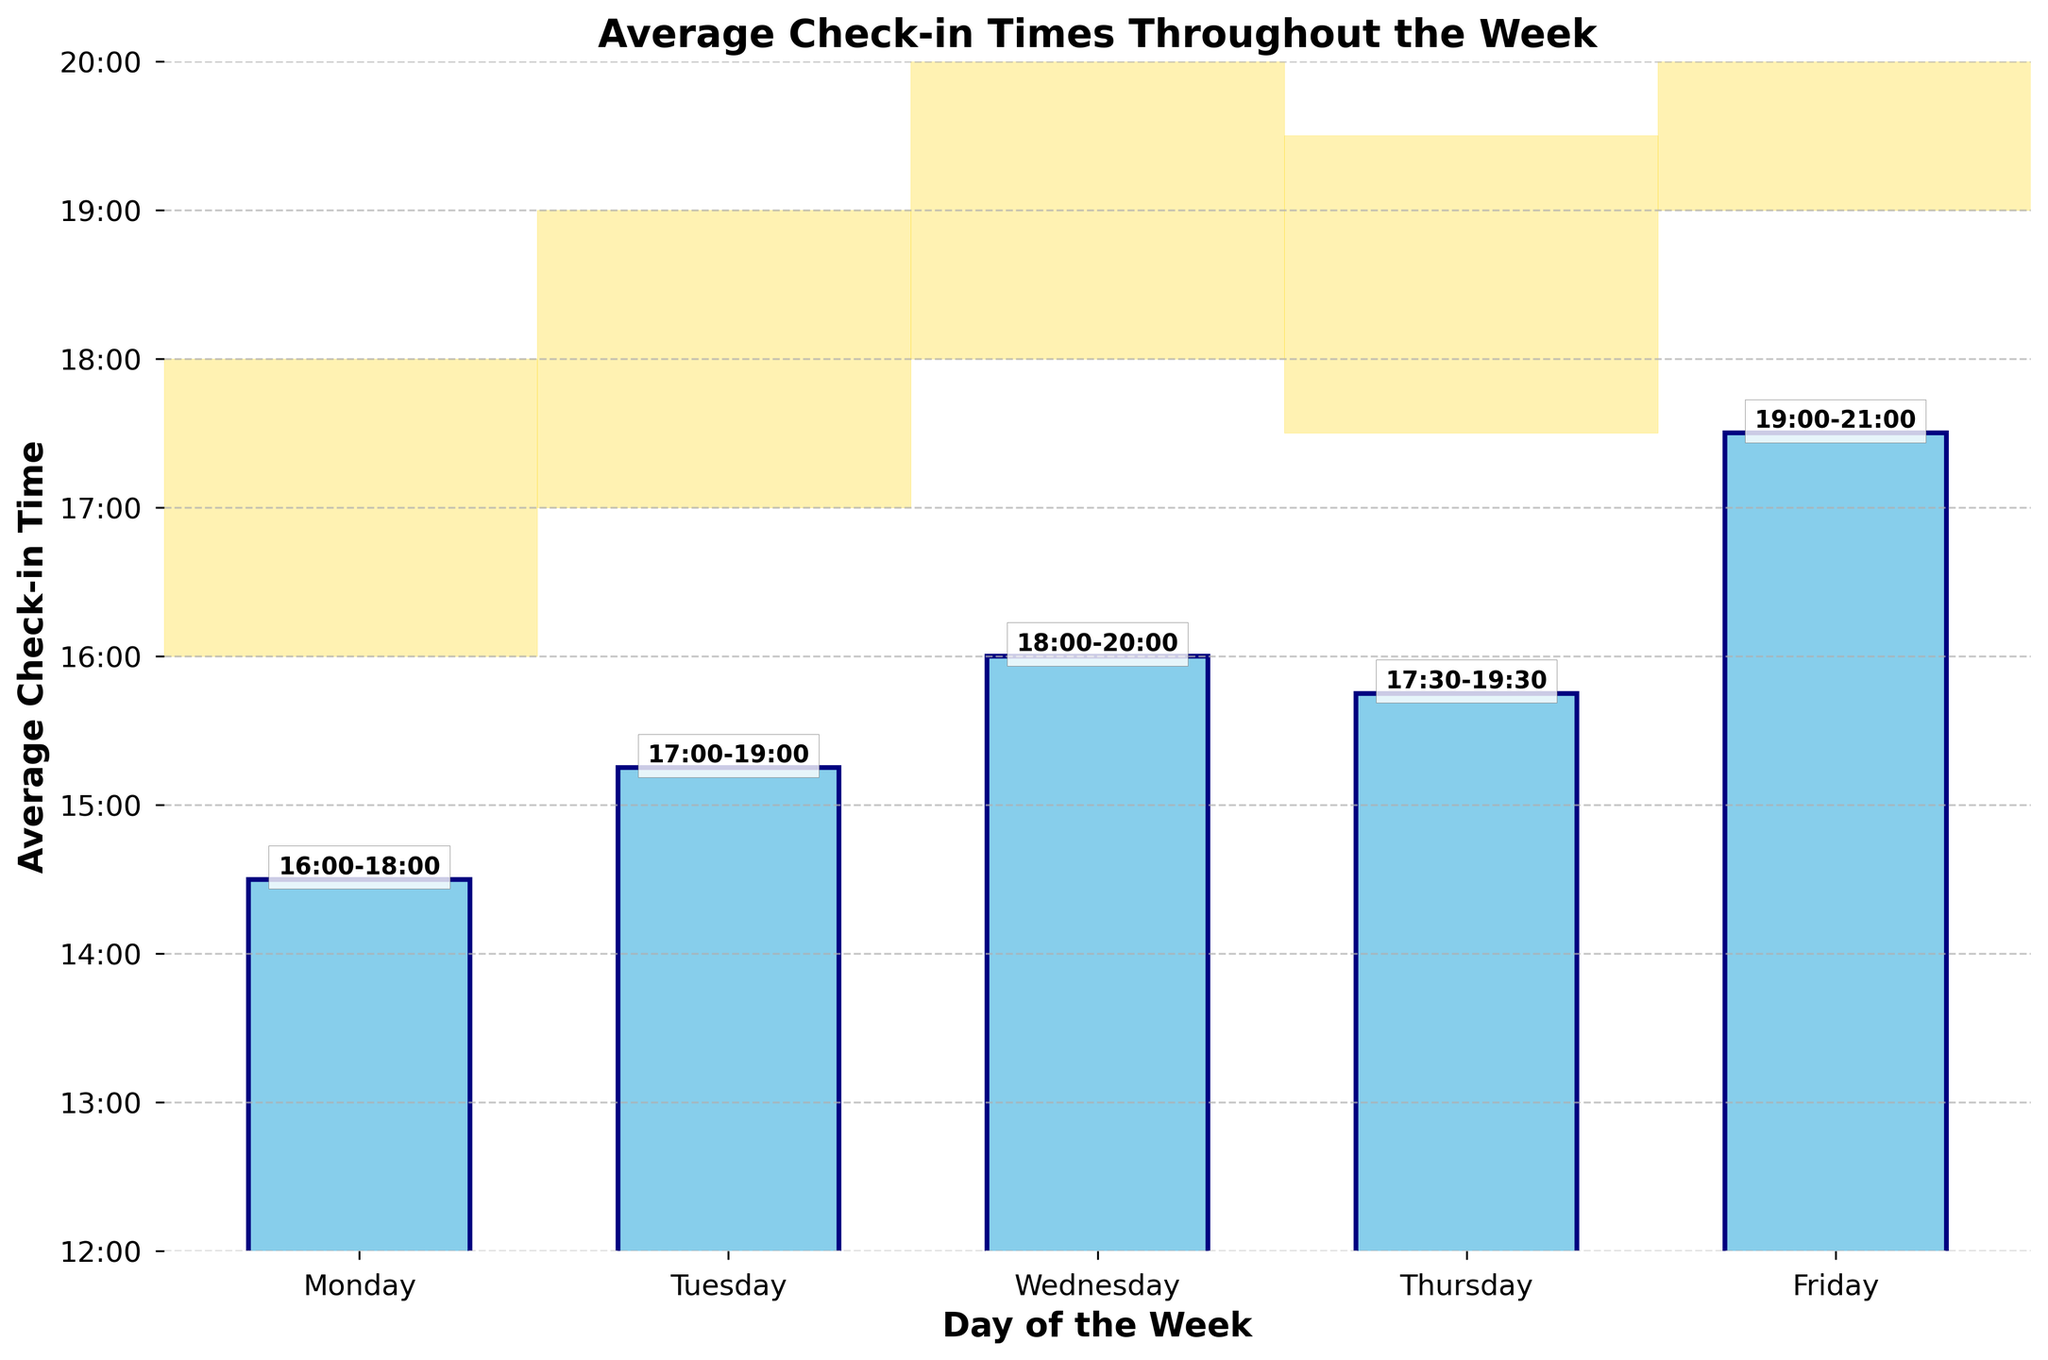What's the peak hour for check-ins on Friday? Look at the bar for Friday and note the highlighted peak hour text above the bar. It indicates peak hours from 19:00 to 21:00.
Answer: 19:00-21:00 What is the difference between the average check-in time on Monday and Friday? Convert the check-in times to hours: Monday is 14.5 hours (14:30) and Friday is 17.5 hours (17:30). Subtract Monday's time from Friday's time: 17.5 - 14.5 = 3 hours.
Answer: 3 hours Which day has the latest average check-in time? Compare the height of the bars on each day. The bar for Friday is the highest, indicating the latest average check-in time.
Answer: Friday By how much is the average check-in time on Wednesday later than on Tuesday? Convert the check-in times to hours: Tuesday is 15.25 hours (15:15) and Wednesday is 16 hours (16:00). Subtract Tuesday's time from Wednesday's time: 16 - 15.25 = 0.75 hours.
Answer: 0.75 hours On which day is the peak check-in time range the earliest? Compare the starting times of the peak hours for each day. Monday's peak hours start at 16:00, which is the earliest.
Answer: Monday How much earlier is the average check-in time on Monday compared to Thursday? Convert the check-in times to hours: Monday is 14.5 hours (14:30) and Thursday is 15.75 hours (15:45). Subtract Thursday's time from Monday's time: 15.75 - 14.5 = 1.25 hours.
Answer: 1.25 hours What is the total duration of the peak check-in hours on Wednesday? Check Wednesday's peak hour range: 18:00 to 20:00. Calculate the duration: 20 - 18 = 2 hours.
Answer: 2 hours How does the average check-in time on Tuesday compare to Thursday? Convert check-in times to hours: Tuesday is 15.25 hours (15:15) and Thursday is 15.75 hours (15:45). Compare the times: Tuesday is earlier than Thursday by 0.5 hours.
Answer: Earlier by 0.5 hours What day has the peak check-in hour range starting the latest? Compare the starting times of the peak hours for each day. Friday's peak hours start at 19:00, which is the latest.
Answer: Friday What's the range of average check-in times throughout the week? Identify the earliest and latest average check-in times: earliest is Monday at 14:30, latest is Friday at 17:30. Calculate the range: 17.5 - 14.5 = 3 hours.
Answer: 3 hours 